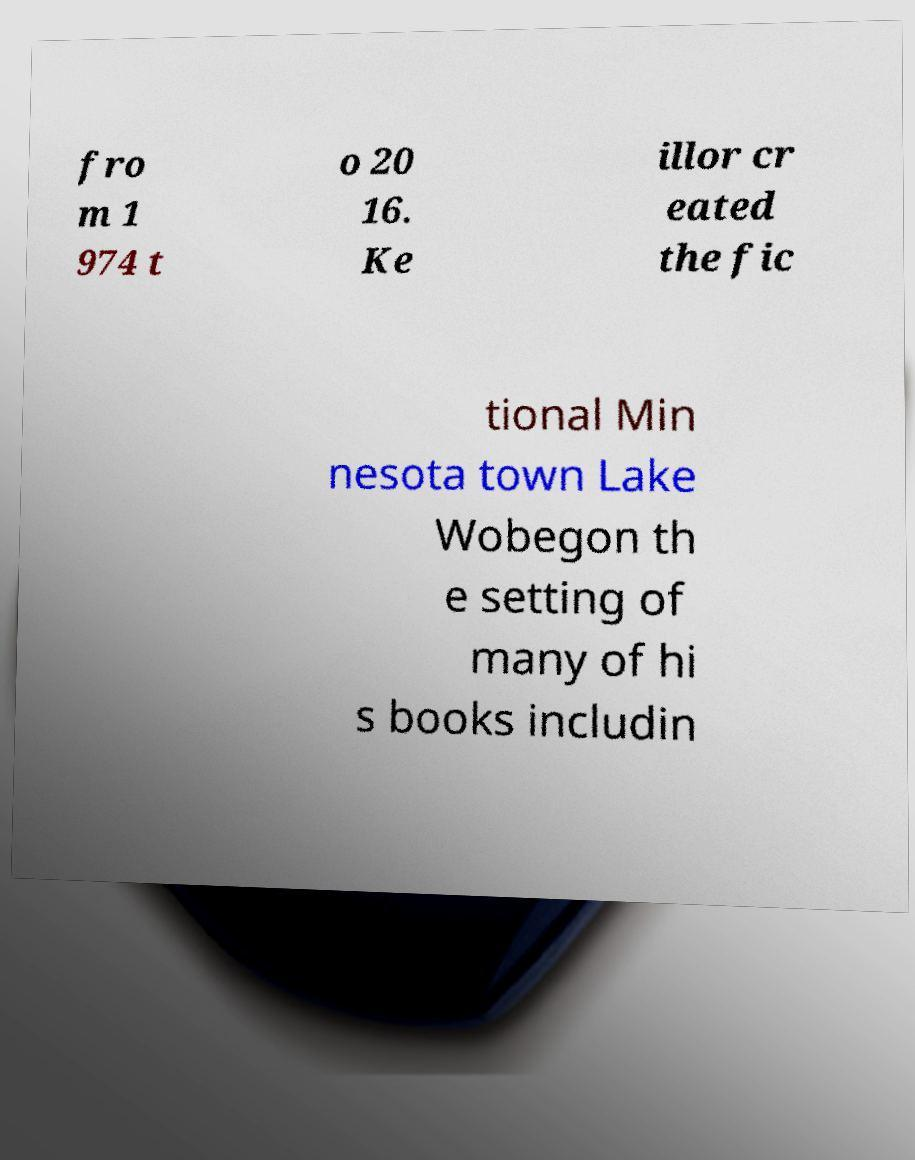There's text embedded in this image that I need extracted. Can you transcribe it verbatim? fro m 1 974 t o 20 16. Ke illor cr eated the fic tional Min nesota town Lake Wobegon th e setting of many of hi s books includin 